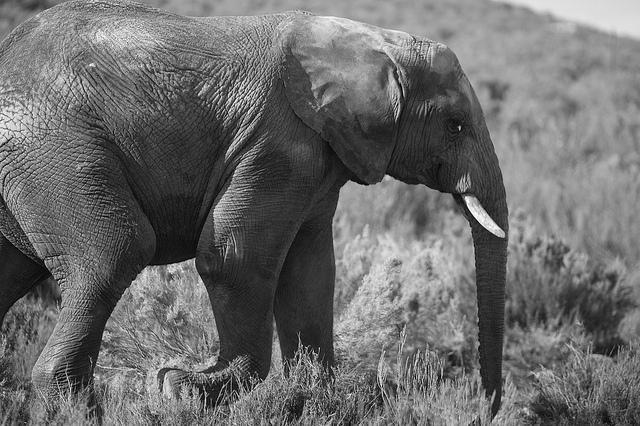How many chopped tree trunks are shown in front of the elephant?
Give a very brief answer. 0. How many elephants are there?
Give a very brief answer. 1. 